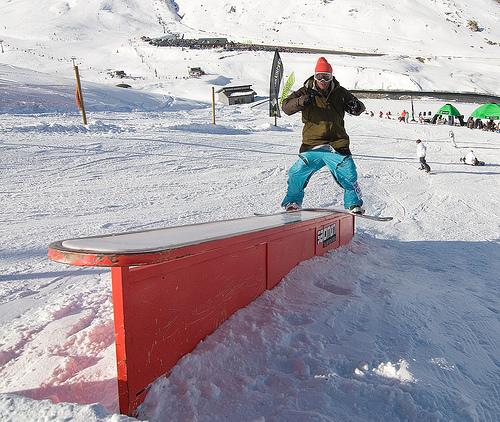Will this person jump down from this platform?
Give a very brief answer. Yes. What is on the ground?
Be succinct. Snow. What is in the man's hands?
Be succinct. Nothing. What are the green objects in the background?
Be succinct. Tents. 